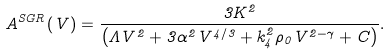Convert formula to latex. <formula><loc_0><loc_0><loc_500><loc_500>A ^ { S G R } \left ( V \right ) = \frac { 3 K ^ { 2 } } { \left ( \Lambda V ^ { 2 } + 3 \alpha ^ { 2 } V ^ { 4 / 3 } + k _ { 4 } ^ { 2 } \rho _ { 0 } V ^ { 2 - \gamma } + C \right ) } .</formula> 